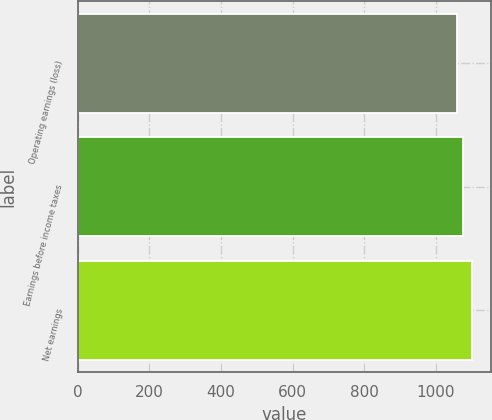Convert chart. <chart><loc_0><loc_0><loc_500><loc_500><bar_chart><fcel>Operating earnings (loss)<fcel>Earnings before income taxes<fcel>Net earnings<nl><fcel>1058.7<fcel>1074.6<fcel>1100<nl></chart> 